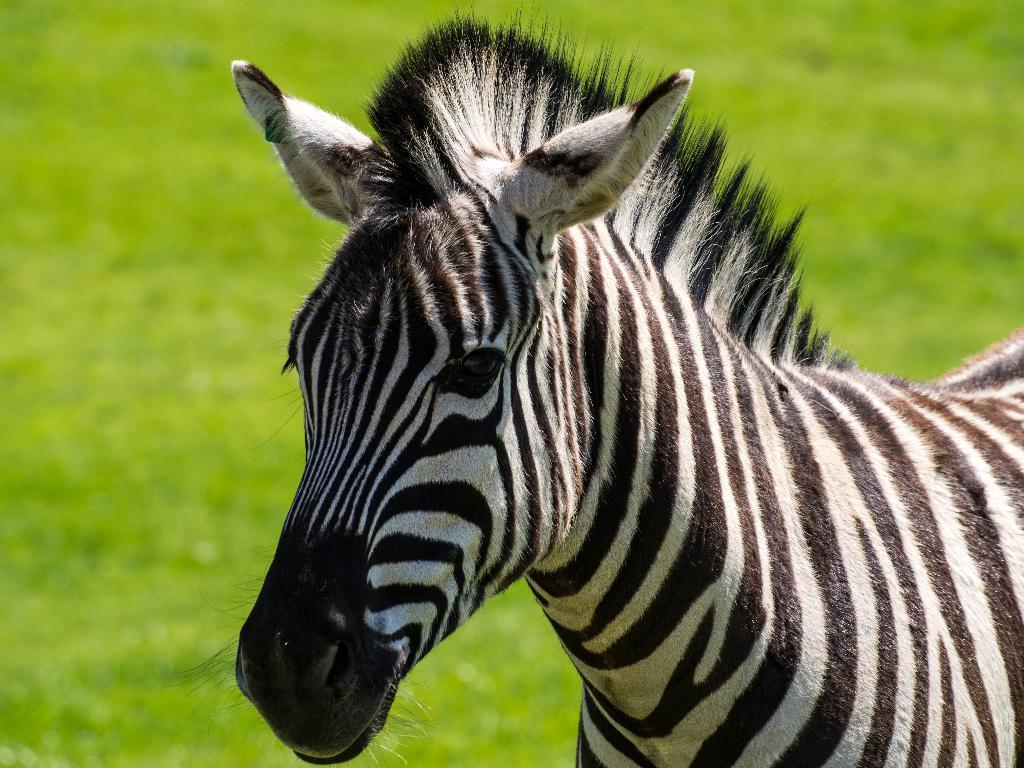What animal is the main subject of the picture? There is a zebra in the picture. Where is the zebra positioned in the image? The zebra is standing in the front. What type of vegetation is visible at the bottom of the picture? There is grass at the bottom of the picture. What type of agreement is being signed by the zebra in the image? There is no indication in the image that the zebra is signing any agreement, as zebras do not have the ability to sign documents. 